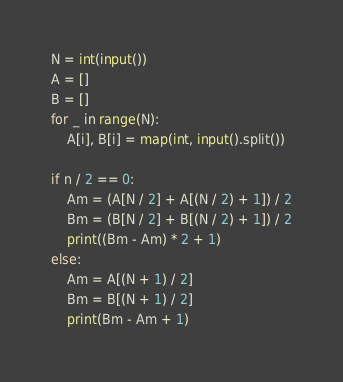<code> <loc_0><loc_0><loc_500><loc_500><_Python_>N = int(input())
A = []
B = []
for _ in range(N):
    A[i], B[i] = map(int, input().split())

if n / 2 == 0:
    Am = (A[N / 2] + A[(N / 2) + 1]) / 2
    Bm = (B[N / 2] + B[(N / 2) + 1]) / 2
    print((Bm - Am) * 2 + 1)
else:
    Am = A[(N + 1) / 2]
    Bm = B[(N + 1) / 2]
    print(Bm - Am + 1)</code> 